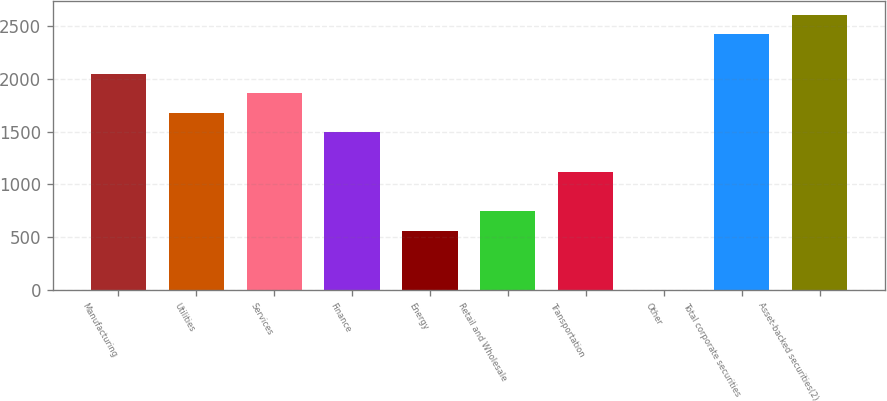Convert chart to OTSL. <chart><loc_0><loc_0><loc_500><loc_500><bar_chart><fcel>Manufacturing<fcel>Utilities<fcel>Services<fcel>Finance<fcel>Energy<fcel>Retail and Wholesale<fcel>Transportation<fcel>Other<fcel>Total corporate securities<fcel>Asset-backed securities(2)<nl><fcel>2050.3<fcel>1677.64<fcel>1863.97<fcel>1491.31<fcel>559.66<fcel>745.99<fcel>1118.65<fcel>0.67<fcel>2422.96<fcel>2609.29<nl></chart> 